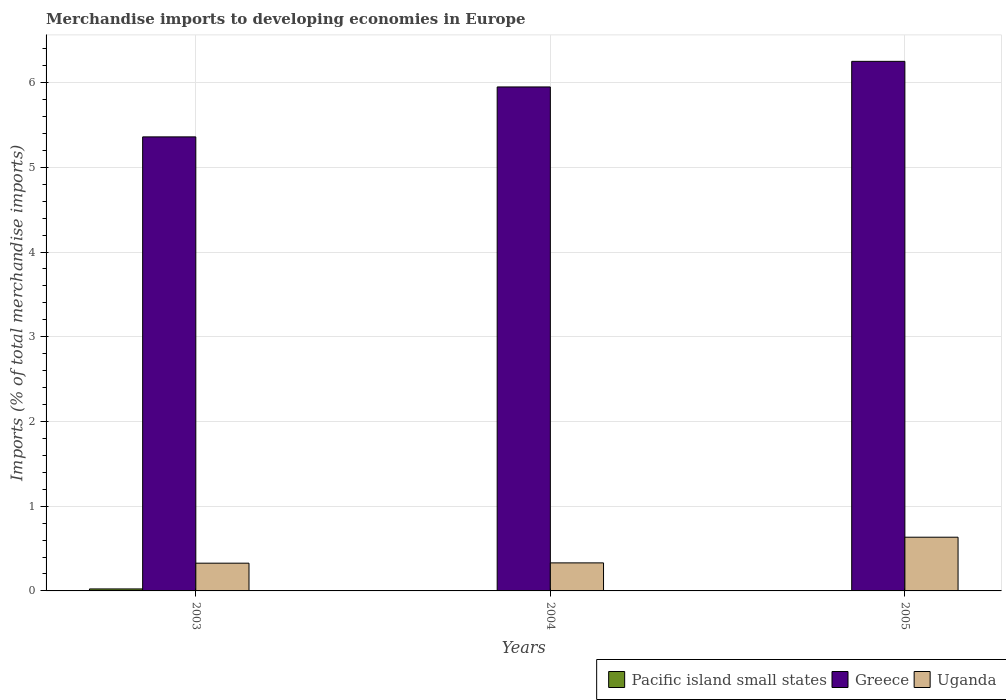How many different coloured bars are there?
Offer a very short reply. 3. How many groups of bars are there?
Provide a short and direct response. 3. Are the number of bars on each tick of the X-axis equal?
Make the answer very short. Yes. How many bars are there on the 3rd tick from the left?
Make the answer very short. 3. How many bars are there on the 1st tick from the right?
Give a very brief answer. 3. What is the label of the 3rd group of bars from the left?
Your answer should be very brief. 2005. In how many cases, is the number of bars for a given year not equal to the number of legend labels?
Ensure brevity in your answer.  0. What is the percentage total merchandise imports in Pacific island small states in 2003?
Your response must be concise. 0.02. Across all years, what is the maximum percentage total merchandise imports in Pacific island small states?
Your answer should be very brief. 0.02. Across all years, what is the minimum percentage total merchandise imports in Pacific island small states?
Make the answer very short. 0. What is the total percentage total merchandise imports in Greece in the graph?
Offer a terse response. 17.56. What is the difference between the percentage total merchandise imports in Pacific island small states in 2004 and that in 2005?
Offer a very short reply. 0. What is the difference between the percentage total merchandise imports in Pacific island small states in 2003 and the percentage total merchandise imports in Uganda in 2004?
Make the answer very short. -0.31. What is the average percentage total merchandise imports in Greece per year?
Offer a terse response. 5.85. In the year 2003, what is the difference between the percentage total merchandise imports in Uganda and percentage total merchandise imports in Pacific island small states?
Offer a terse response. 0.3. In how many years, is the percentage total merchandise imports in Greece greater than 5.4 %?
Your response must be concise. 2. What is the ratio of the percentage total merchandise imports in Greece in 2003 to that in 2005?
Offer a very short reply. 0.86. Is the percentage total merchandise imports in Pacific island small states in 2004 less than that in 2005?
Make the answer very short. No. What is the difference between the highest and the second highest percentage total merchandise imports in Uganda?
Your answer should be compact. 0.3. What is the difference between the highest and the lowest percentage total merchandise imports in Pacific island small states?
Keep it short and to the point. 0.02. Is the sum of the percentage total merchandise imports in Uganda in 2003 and 2004 greater than the maximum percentage total merchandise imports in Greece across all years?
Your answer should be compact. No. What does the 3rd bar from the left in 2004 represents?
Your answer should be compact. Uganda. What does the 3rd bar from the right in 2004 represents?
Offer a terse response. Pacific island small states. How many bars are there?
Give a very brief answer. 9. Are all the bars in the graph horizontal?
Provide a succinct answer. No. How many years are there in the graph?
Give a very brief answer. 3. Does the graph contain any zero values?
Your response must be concise. No. Does the graph contain grids?
Your answer should be compact. Yes. How many legend labels are there?
Keep it short and to the point. 3. How are the legend labels stacked?
Provide a short and direct response. Horizontal. What is the title of the graph?
Your answer should be very brief. Merchandise imports to developing economies in Europe. Does "France" appear as one of the legend labels in the graph?
Give a very brief answer. No. What is the label or title of the Y-axis?
Provide a short and direct response. Imports (% of total merchandise imports). What is the Imports (% of total merchandise imports) in Pacific island small states in 2003?
Your response must be concise. 0.02. What is the Imports (% of total merchandise imports) in Greece in 2003?
Provide a succinct answer. 5.36. What is the Imports (% of total merchandise imports) in Uganda in 2003?
Your response must be concise. 0.33. What is the Imports (% of total merchandise imports) in Pacific island small states in 2004?
Make the answer very short. 0. What is the Imports (% of total merchandise imports) in Greece in 2004?
Keep it short and to the point. 5.95. What is the Imports (% of total merchandise imports) in Uganda in 2004?
Your answer should be very brief. 0.33. What is the Imports (% of total merchandise imports) of Pacific island small states in 2005?
Offer a terse response. 0. What is the Imports (% of total merchandise imports) of Greece in 2005?
Your answer should be compact. 6.25. What is the Imports (% of total merchandise imports) in Uganda in 2005?
Ensure brevity in your answer.  0.63. Across all years, what is the maximum Imports (% of total merchandise imports) of Pacific island small states?
Your answer should be very brief. 0.02. Across all years, what is the maximum Imports (% of total merchandise imports) in Greece?
Offer a very short reply. 6.25. Across all years, what is the maximum Imports (% of total merchandise imports) of Uganda?
Give a very brief answer. 0.63. Across all years, what is the minimum Imports (% of total merchandise imports) of Pacific island small states?
Give a very brief answer. 0. Across all years, what is the minimum Imports (% of total merchandise imports) of Greece?
Give a very brief answer. 5.36. Across all years, what is the minimum Imports (% of total merchandise imports) of Uganda?
Provide a succinct answer. 0.33. What is the total Imports (% of total merchandise imports) in Pacific island small states in the graph?
Ensure brevity in your answer.  0.03. What is the total Imports (% of total merchandise imports) of Greece in the graph?
Provide a short and direct response. 17.56. What is the total Imports (% of total merchandise imports) of Uganda in the graph?
Offer a terse response. 1.29. What is the difference between the Imports (% of total merchandise imports) in Pacific island small states in 2003 and that in 2004?
Offer a terse response. 0.02. What is the difference between the Imports (% of total merchandise imports) in Greece in 2003 and that in 2004?
Offer a very short reply. -0.59. What is the difference between the Imports (% of total merchandise imports) in Uganda in 2003 and that in 2004?
Offer a very short reply. -0. What is the difference between the Imports (% of total merchandise imports) of Pacific island small states in 2003 and that in 2005?
Your answer should be compact. 0.02. What is the difference between the Imports (% of total merchandise imports) in Greece in 2003 and that in 2005?
Your response must be concise. -0.89. What is the difference between the Imports (% of total merchandise imports) of Uganda in 2003 and that in 2005?
Your answer should be compact. -0.31. What is the difference between the Imports (% of total merchandise imports) of Pacific island small states in 2004 and that in 2005?
Offer a terse response. 0. What is the difference between the Imports (% of total merchandise imports) in Greece in 2004 and that in 2005?
Ensure brevity in your answer.  -0.3. What is the difference between the Imports (% of total merchandise imports) of Uganda in 2004 and that in 2005?
Ensure brevity in your answer.  -0.3. What is the difference between the Imports (% of total merchandise imports) in Pacific island small states in 2003 and the Imports (% of total merchandise imports) in Greece in 2004?
Provide a short and direct response. -5.92. What is the difference between the Imports (% of total merchandise imports) of Pacific island small states in 2003 and the Imports (% of total merchandise imports) of Uganda in 2004?
Offer a terse response. -0.31. What is the difference between the Imports (% of total merchandise imports) in Greece in 2003 and the Imports (% of total merchandise imports) in Uganda in 2004?
Keep it short and to the point. 5.03. What is the difference between the Imports (% of total merchandise imports) of Pacific island small states in 2003 and the Imports (% of total merchandise imports) of Greece in 2005?
Provide a succinct answer. -6.23. What is the difference between the Imports (% of total merchandise imports) of Pacific island small states in 2003 and the Imports (% of total merchandise imports) of Uganda in 2005?
Give a very brief answer. -0.61. What is the difference between the Imports (% of total merchandise imports) in Greece in 2003 and the Imports (% of total merchandise imports) in Uganda in 2005?
Ensure brevity in your answer.  4.72. What is the difference between the Imports (% of total merchandise imports) of Pacific island small states in 2004 and the Imports (% of total merchandise imports) of Greece in 2005?
Offer a very short reply. -6.25. What is the difference between the Imports (% of total merchandise imports) in Pacific island small states in 2004 and the Imports (% of total merchandise imports) in Uganda in 2005?
Offer a terse response. -0.63. What is the difference between the Imports (% of total merchandise imports) of Greece in 2004 and the Imports (% of total merchandise imports) of Uganda in 2005?
Keep it short and to the point. 5.31. What is the average Imports (% of total merchandise imports) in Pacific island small states per year?
Offer a very short reply. 0.01. What is the average Imports (% of total merchandise imports) of Greece per year?
Your answer should be compact. 5.85. What is the average Imports (% of total merchandise imports) of Uganda per year?
Offer a terse response. 0.43. In the year 2003, what is the difference between the Imports (% of total merchandise imports) of Pacific island small states and Imports (% of total merchandise imports) of Greece?
Give a very brief answer. -5.34. In the year 2003, what is the difference between the Imports (% of total merchandise imports) of Pacific island small states and Imports (% of total merchandise imports) of Uganda?
Provide a succinct answer. -0.3. In the year 2003, what is the difference between the Imports (% of total merchandise imports) in Greece and Imports (% of total merchandise imports) in Uganda?
Offer a very short reply. 5.03. In the year 2004, what is the difference between the Imports (% of total merchandise imports) of Pacific island small states and Imports (% of total merchandise imports) of Greece?
Your answer should be compact. -5.95. In the year 2004, what is the difference between the Imports (% of total merchandise imports) in Pacific island small states and Imports (% of total merchandise imports) in Uganda?
Your answer should be very brief. -0.33. In the year 2004, what is the difference between the Imports (% of total merchandise imports) of Greece and Imports (% of total merchandise imports) of Uganda?
Keep it short and to the point. 5.62. In the year 2005, what is the difference between the Imports (% of total merchandise imports) in Pacific island small states and Imports (% of total merchandise imports) in Greece?
Provide a succinct answer. -6.25. In the year 2005, what is the difference between the Imports (% of total merchandise imports) of Pacific island small states and Imports (% of total merchandise imports) of Uganda?
Provide a succinct answer. -0.63. In the year 2005, what is the difference between the Imports (% of total merchandise imports) of Greece and Imports (% of total merchandise imports) of Uganda?
Your response must be concise. 5.62. What is the ratio of the Imports (% of total merchandise imports) of Pacific island small states in 2003 to that in 2004?
Your response must be concise. 8.3. What is the ratio of the Imports (% of total merchandise imports) of Greece in 2003 to that in 2004?
Offer a very short reply. 0.9. What is the ratio of the Imports (% of total merchandise imports) of Pacific island small states in 2003 to that in 2005?
Your response must be concise. 20.78. What is the ratio of the Imports (% of total merchandise imports) in Greece in 2003 to that in 2005?
Make the answer very short. 0.86. What is the ratio of the Imports (% of total merchandise imports) in Uganda in 2003 to that in 2005?
Your answer should be compact. 0.52. What is the ratio of the Imports (% of total merchandise imports) of Pacific island small states in 2004 to that in 2005?
Provide a succinct answer. 2.5. What is the ratio of the Imports (% of total merchandise imports) in Greece in 2004 to that in 2005?
Make the answer very short. 0.95. What is the ratio of the Imports (% of total merchandise imports) of Uganda in 2004 to that in 2005?
Provide a succinct answer. 0.52. What is the difference between the highest and the second highest Imports (% of total merchandise imports) of Pacific island small states?
Give a very brief answer. 0.02. What is the difference between the highest and the second highest Imports (% of total merchandise imports) in Greece?
Your answer should be compact. 0.3. What is the difference between the highest and the second highest Imports (% of total merchandise imports) of Uganda?
Give a very brief answer. 0.3. What is the difference between the highest and the lowest Imports (% of total merchandise imports) of Pacific island small states?
Provide a succinct answer. 0.02. What is the difference between the highest and the lowest Imports (% of total merchandise imports) of Greece?
Your response must be concise. 0.89. What is the difference between the highest and the lowest Imports (% of total merchandise imports) in Uganda?
Keep it short and to the point. 0.31. 